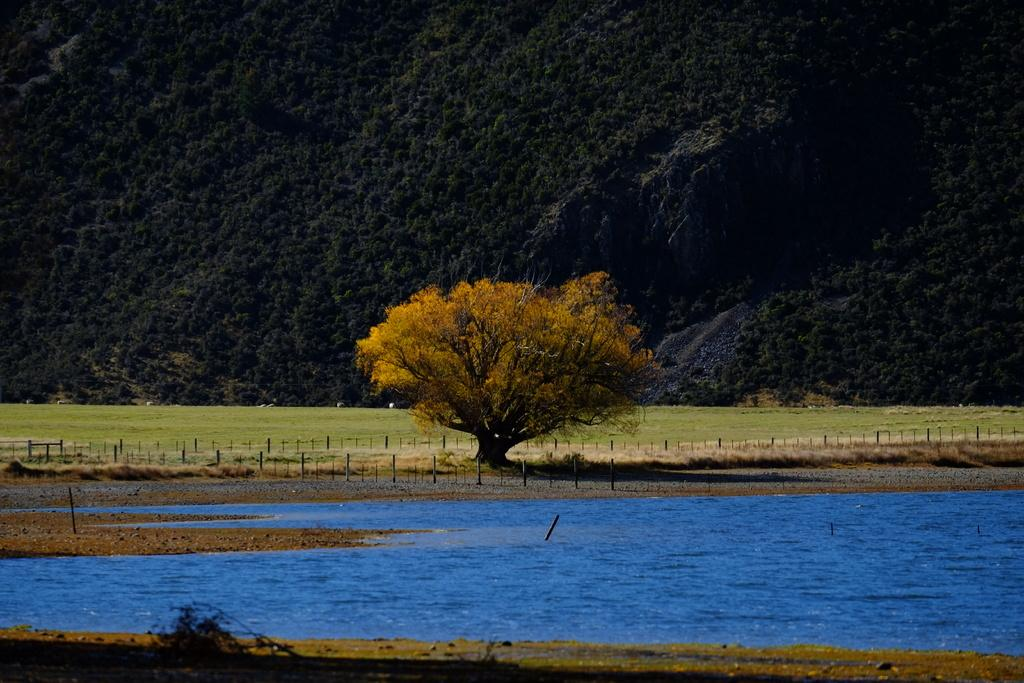What type of natural feature is present in the image? There is a river in the image. What objects can be seen near the river? Wooden rods are visible in the image. What geographical feature is located in the background of the image? There are trees on a mountain in the image. What type of punishment is being carried out near the river in the image? There is no indication of any punishment being carried out in the image; it simply shows a river, wooden rods, and trees on a mountain. What date is shown on the calendar near the river in the image? There is no calendar present in the image; it only features a river, wooden rods, and trees on a mountain. 